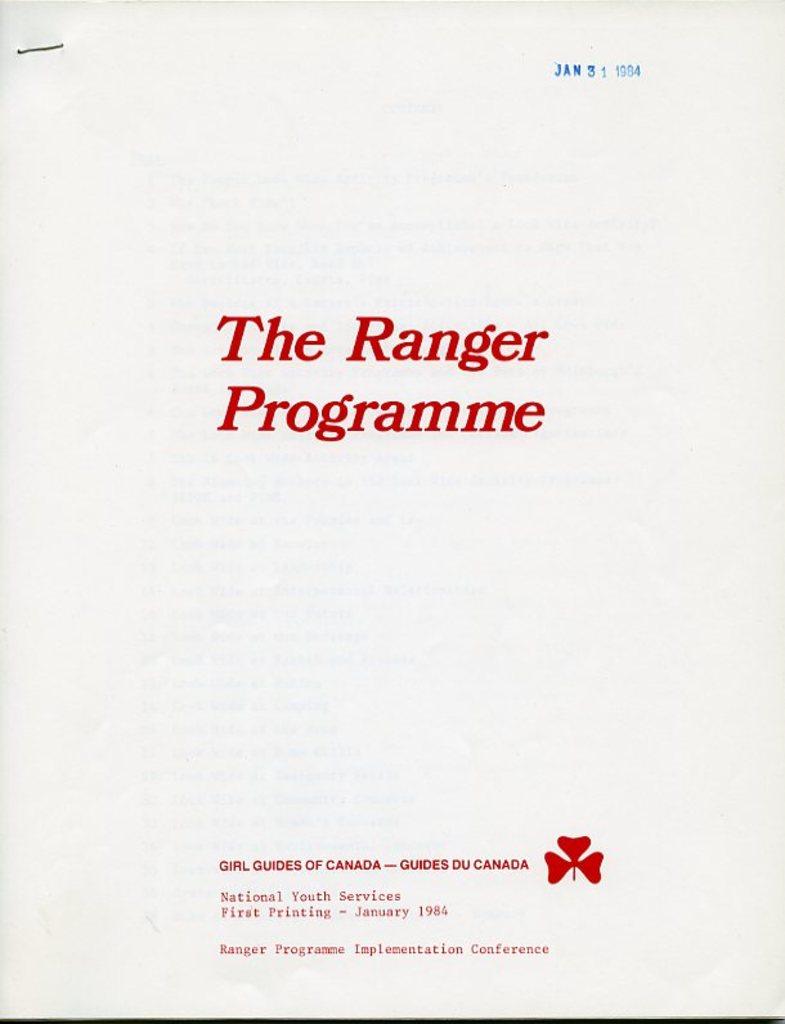What is the title of this document?
Provide a short and direct response. The ranger programme. When was this printed?
Provide a short and direct response. January 1984. 